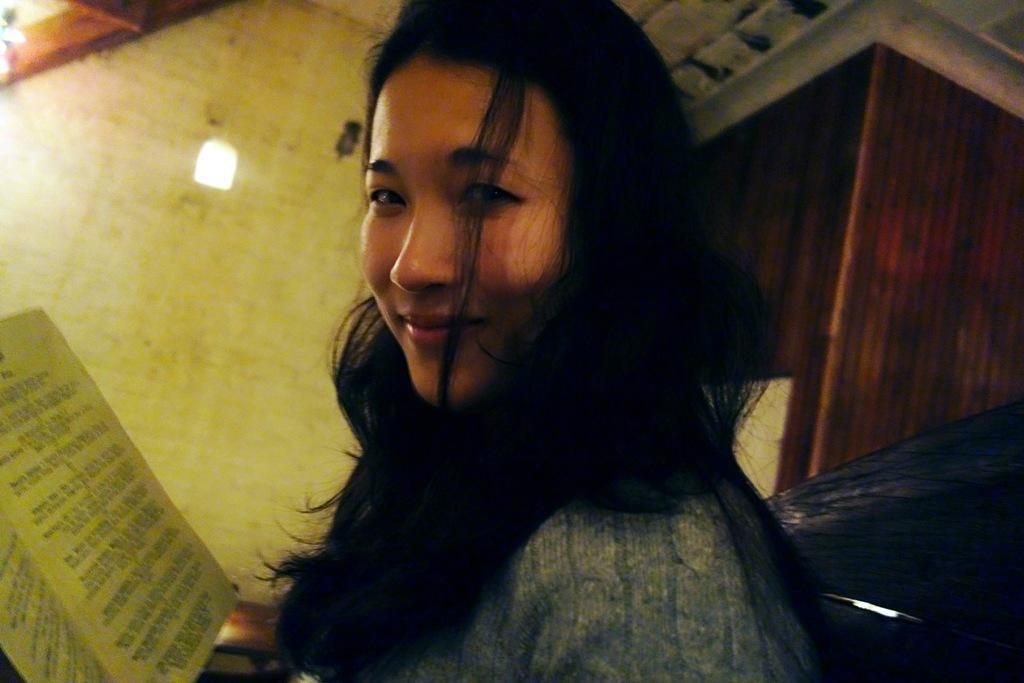How would you summarize this image in a sentence or two? In this picture there is a woman smiling and we can see book. In the background of the image we can see wall, light and objects. 